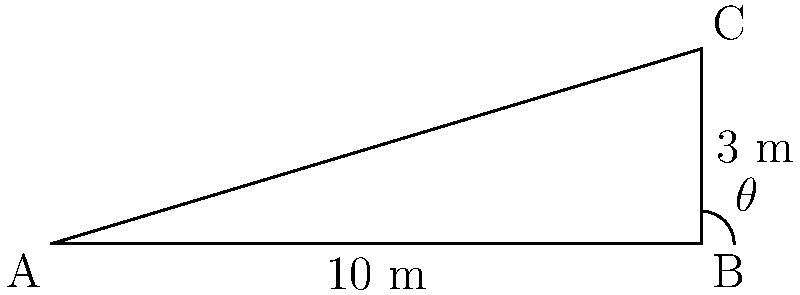A medical supply vehicle needs to unload heavy equipment using a ramp. The vehicle's cargo bed is 3 meters high, and the maximum safe ramp length is 10 meters. What is the optimal angle $\theta$ (in degrees) for the loading ramp to ensure safe unloading while maximizing stability? To find the optimal angle $\theta$, we can use trigonometry in the right-angled triangle formed by the ramp:

1) The adjacent side (horizontal distance) is 10 meters, and the opposite side (height) is 3 meters.

2) We can use the tangent function to find the angle:

   $\tan(\theta) = \frac{\text{opposite}}{\text{adjacent}} = \frac{3}{10} = 0.3$

3) To find $\theta$, we need to use the inverse tangent (arctan or $\tan^{-1}$):

   $\theta = \tan^{-1}(0.3)$

4) Using a calculator or trigonometric tables:

   $\theta \approx 16.70^\circ$

5) Rounding to the nearest degree for practical application:

   $\theta \approx 17^\circ$

This angle provides a good balance between a gentle slope for safe unloading and stability of the ramp.
Answer: $17^\circ$ 